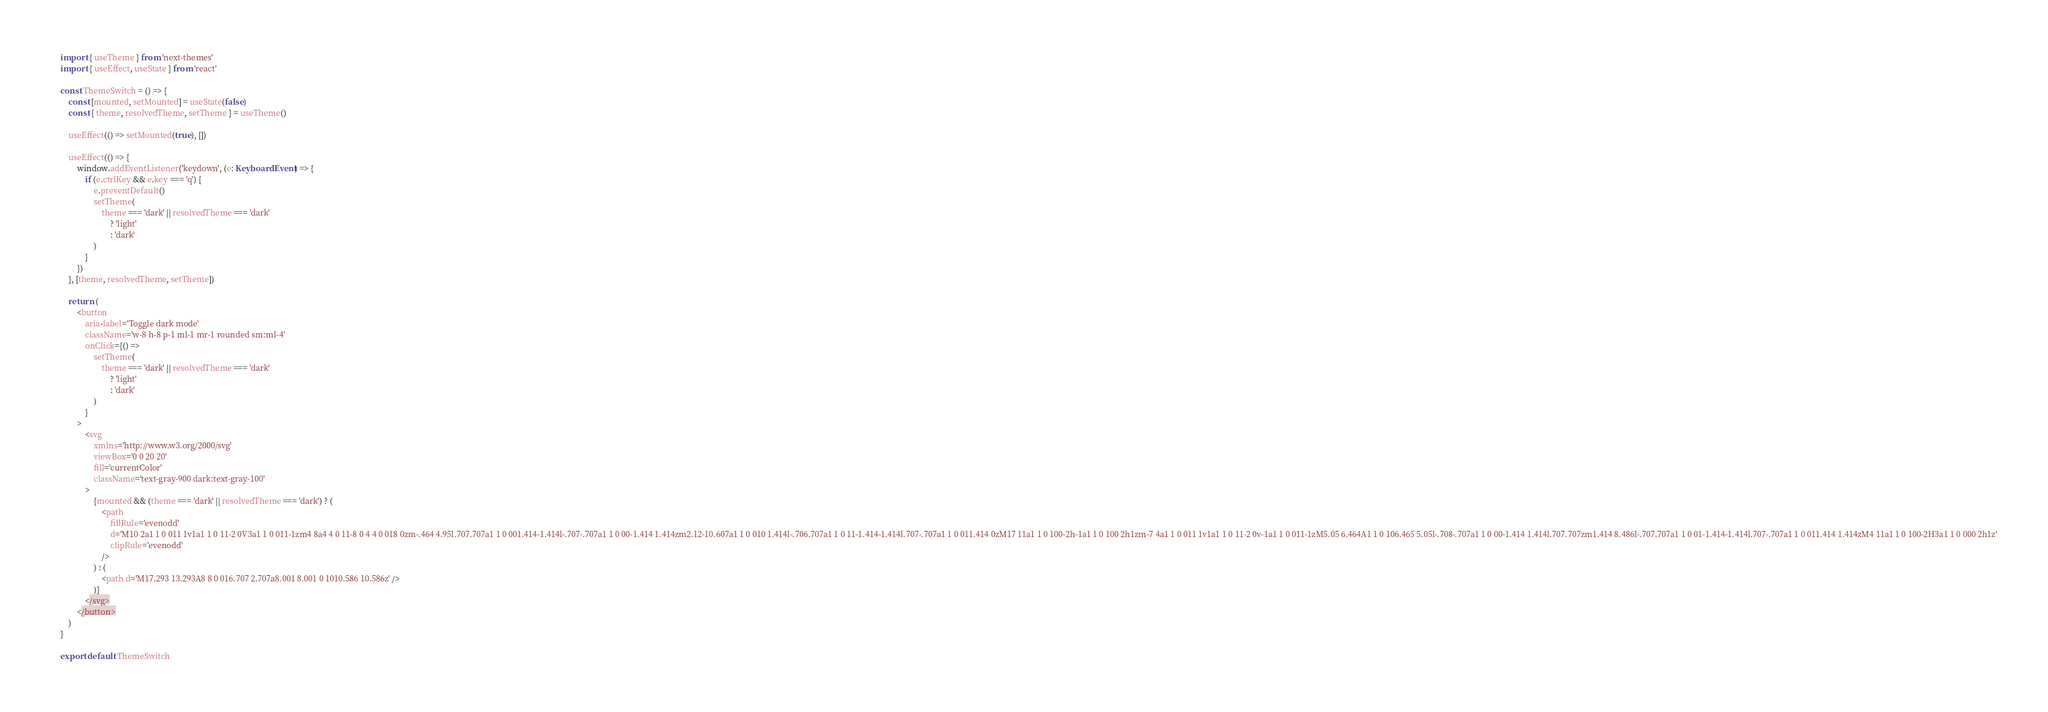<code> <loc_0><loc_0><loc_500><loc_500><_TypeScript_>import { useTheme } from 'next-themes'
import { useEffect, useState } from 'react'

const ThemeSwitch = () => {
    const [mounted, setMounted] = useState(false)
    const { theme, resolvedTheme, setTheme } = useTheme()

    useEffect(() => setMounted(true), [])

    useEffect(() => {
        window.addEventListener('keydown', (e: KeyboardEvent) => {
            if (e.ctrlKey && e.key === 'q') {
                e.preventDefault()
                setTheme(
                    theme === 'dark' || resolvedTheme === 'dark'
                        ? 'light'
                        : 'dark'
                )
            }
        })
    }, [theme, resolvedTheme, setTheme])

    return (
        <button
            aria-label='Toggle dark mode'
            className='w-8 h-8 p-1 ml-1 mr-1 rounded sm:ml-4'
            onClick={() =>
                setTheme(
                    theme === 'dark' || resolvedTheme === 'dark'
                        ? 'light'
                        : 'dark'
                )
            }
        >
            <svg
                xmlns='http://www.w3.org/2000/svg'
                viewBox='0 0 20 20'
                fill='currentColor'
                className='text-gray-900 dark:text-gray-100'
            >
                {mounted && (theme === 'dark' || resolvedTheme === 'dark') ? (
                    <path
                        fillRule='evenodd'
                        d='M10 2a1 1 0 011 1v1a1 1 0 11-2 0V3a1 1 0 011-1zm4 8a4 4 0 11-8 0 4 4 0 018 0zm-.464 4.95l.707.707a1 1 0 001.414-1.414l-.707-.707a1 1 0 00-1.414 1.414zm2.12-10.607a1 1 0 010 1.414l-.706.707a1 1 0 11-1.414-1.414l.707-.707a1 1 0 011.414 0zM17 11a1 1 0 100-2h-1a1 1 0 100 2h1zm-7 4a1 1 0 011 1v1a1 1 0 11-2 0v-1a1 1 0 011-1zM5.05 6.464A1 1 0 106.465 5.05l-.708-.707a1 1 0 00-1.414 1.414l.707.707zm1.414 8.486l-.707.707a1 1 0 01-1.414-1.414l.707-.707a1 1 0 011.414 1.414zM4 11a1 1 0 100-2H3a1 1 0 000 2h1z'
                        clipRule='evenodd'
                    />
                ) : (
                    <path d='M17.293 13.293A8 8 0 016.707 2.707a8.001 8.001 0 1010.586 10.586z' />
                )}
            </svg>
        </button>
    )
}

export default ThemeSwitch
</code> 